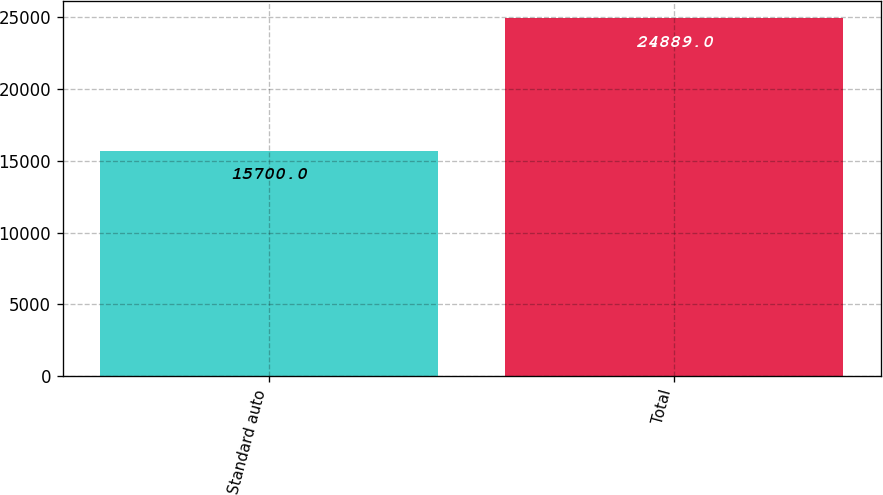<chart> <loc_0><loc_0><loc_500><loc_500><bar_chart><fcel>Standard auto<fcel>Total<nl><fcel>15700<fcel>24889<nl></chart> 